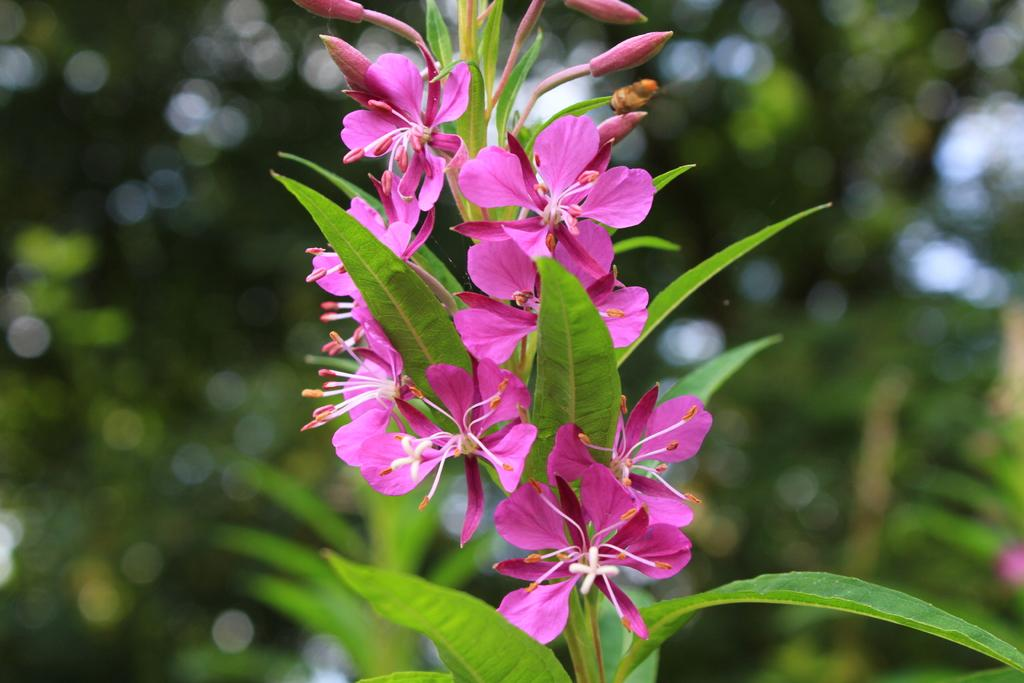What type of living organisms can be seen in the image? Plants can be seen in the image. What stage of growth are the plants in? There are buds in the image, indicating that the plants are in the early stages of growth. What parts of the plants are visible in the image? There are leaves on the stems in the image. What can be seen in the background of the image? There are blurred trees in the background of the image. What type of battle is taking place in the image? There is no battle present in the image; it features plants with buds and leaves on stems, as well as blurred trees in the background. 